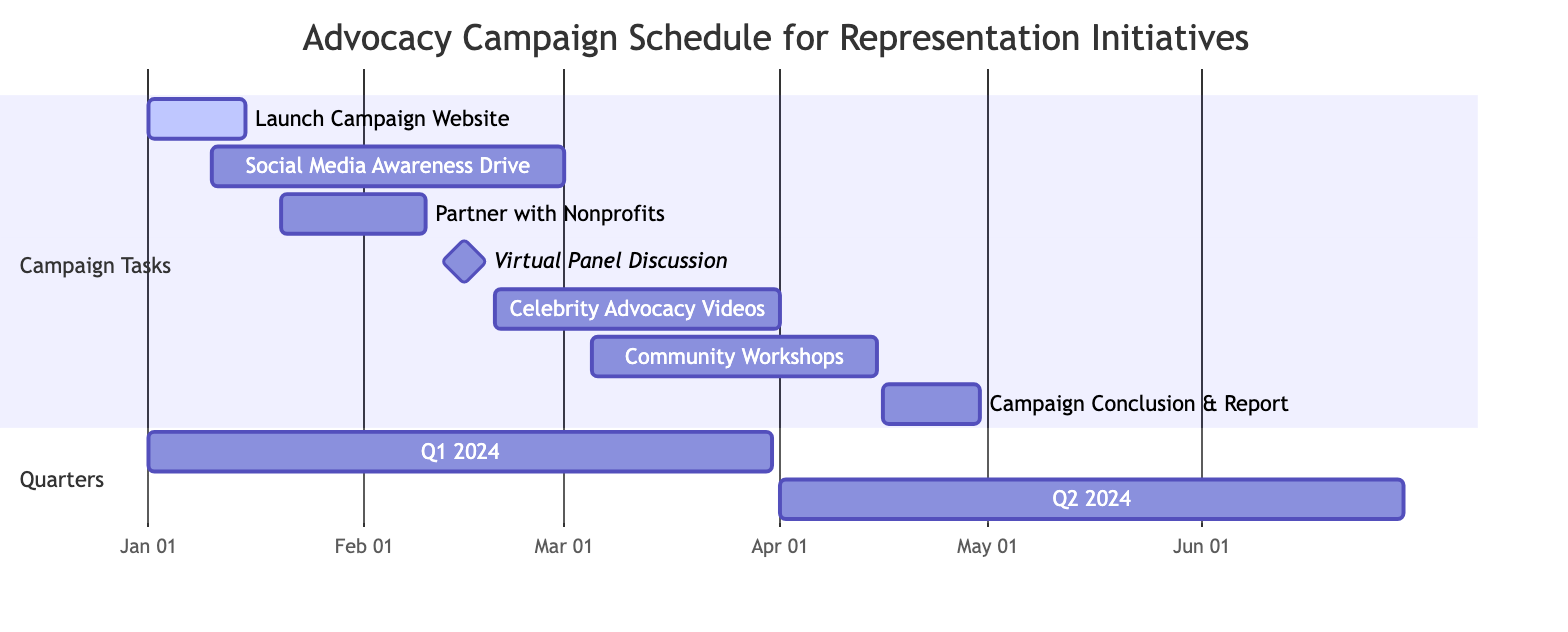What is the duration of the "Launch Campaign Website" task? The task starts on January 1, 2024, and ends on January 15, 2024. To calculate the duration, count the number of days between the start and end dates, which is 15 days in total (including both end dates).
Answer: 15 days Which task is scheduled immediately after the "Partner with Nonprofits"? "Partner with Nonprofits" ends on February 10, 2024. The next task, "Virtual Panel Discussion," starts on February 15, 2024. This means "Virtual Panel Discussion" immediately follows "Partner with Nonprofits" with a gap of 5 days.
Answer: Virtual Panel Discussion How many tasks are planned to start or end in February 2024? In February 2024, the tasks that start are "Partner with Nonprofits" (February 20), "Virtual Panel Discussion" (February 15), and "Celebrity Advocacy Videos" (February 20). "Partner with Nonprofits" ends on February 10, and "Virtual Panel Discussion" ends on the same day it starts. Thus, there are 5 tasks either starting or ending in February.
Answer: 5 tasks What is the total span of the campaign from start to end? The campaign begins on January 1, 2024 (Launch Campaign Website) and concludes on April 30, 2024 (Campaign Conclusion and Report). To find the total span, subtract the start date from the end date, which gives a total of 120 days.
Answer: 120 days Which task lasts the longest duration? To determine which task lasts the longest, we calculate the duration of each task. Comparing the durations: "Community Engagement Workshops" (41 days), "Celebrity Advocacy Videos" (40 days), and all others, we find that "Community Engagement Workshops" spans the longest time.
Answer: Community Engagement Workshops 